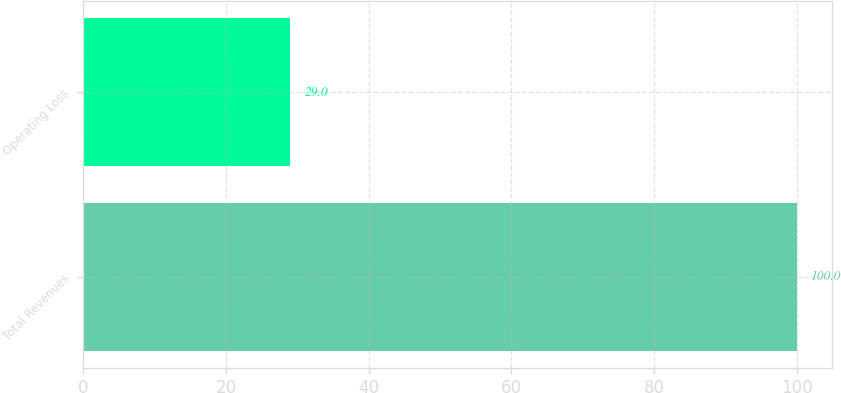Convert chart. <chart><loc_0><loc_0><loc_500><loc_500><bar_chart><fcel>Total Revenues<fcel>Operating Loss<nl><fcel>100<fcel>29<nl></chart> 